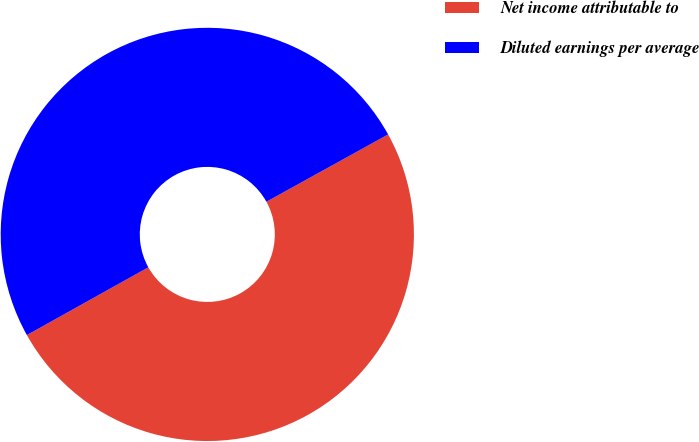<chart> <loc_0><loc_0><loc_500><loc_500><pie_chart><fcel>Net income attributable to<fcel>Diluted earnings per average<nl><fcel>49.94%<fcel>50.06%<nl></chart> 